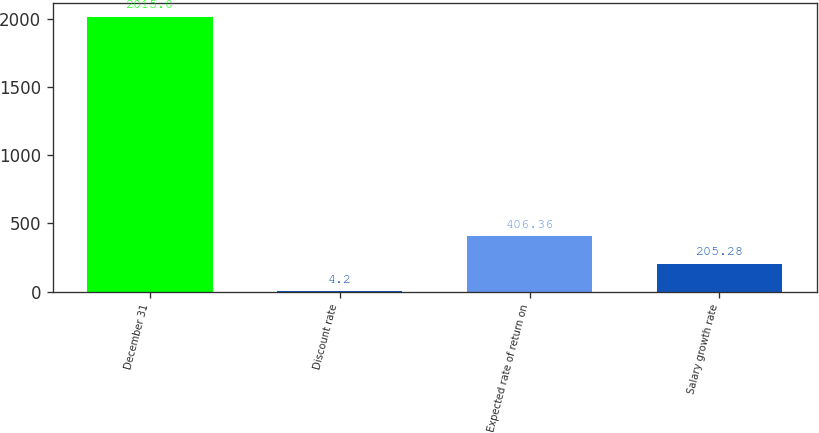Convert chart to OTSL. <chart><loc_0><loc_0><loc_500><loc_500><bar_chart><fcel>December 31<fcel>Discount rate<fcel>Expected rate of return on<fcel>Salary growth rate<nl><fcel>2015<fcel>4.2<fcel>406.36<fcel>205.28<nl></chart> 